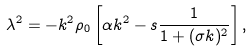Convert formula to latex. <formula><loc_0><loc_0><loc_500><loc_500>\lambda ^ { 2 } = - k ^ { 2 } \rho _ { 0 } \left [ \alpha k ^ { 2 } - s \frac { 1 } { 1 + ( \sigma k ) ^ { 2 } } \right ] ,</formula> 